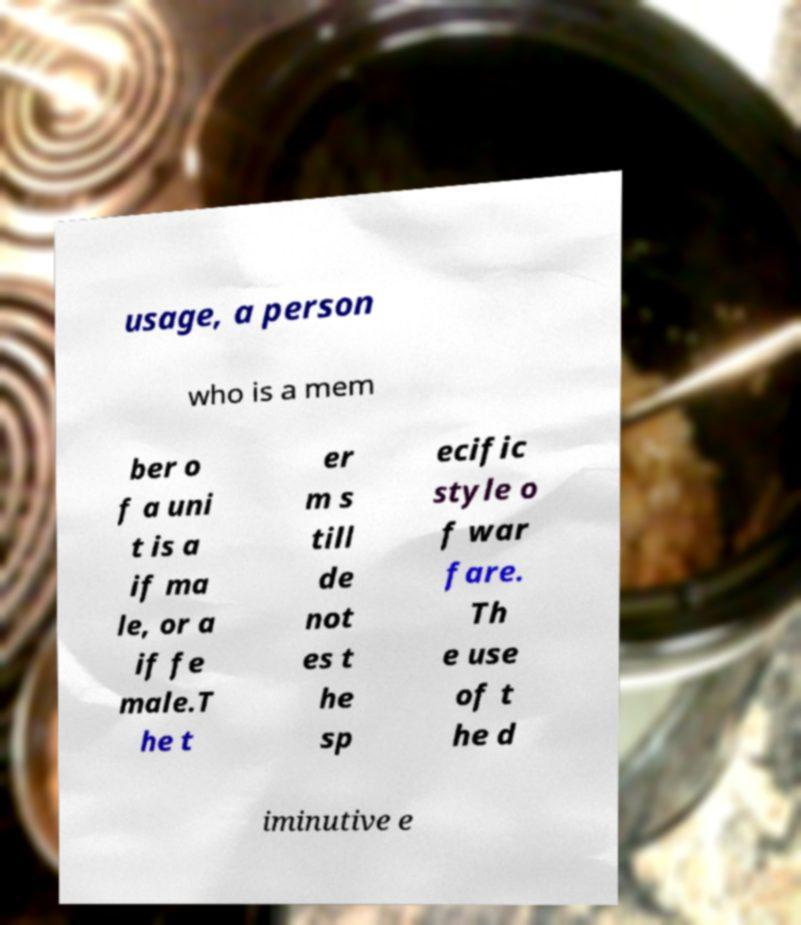Please identify and transcribe the text found in this image. usage, a person who is a mem ber o f a uni t is a if ma le, or a if fe male.T he t er m s till de not es t he sp ecific style o f war fare. Th e use of t he d iminutive e 